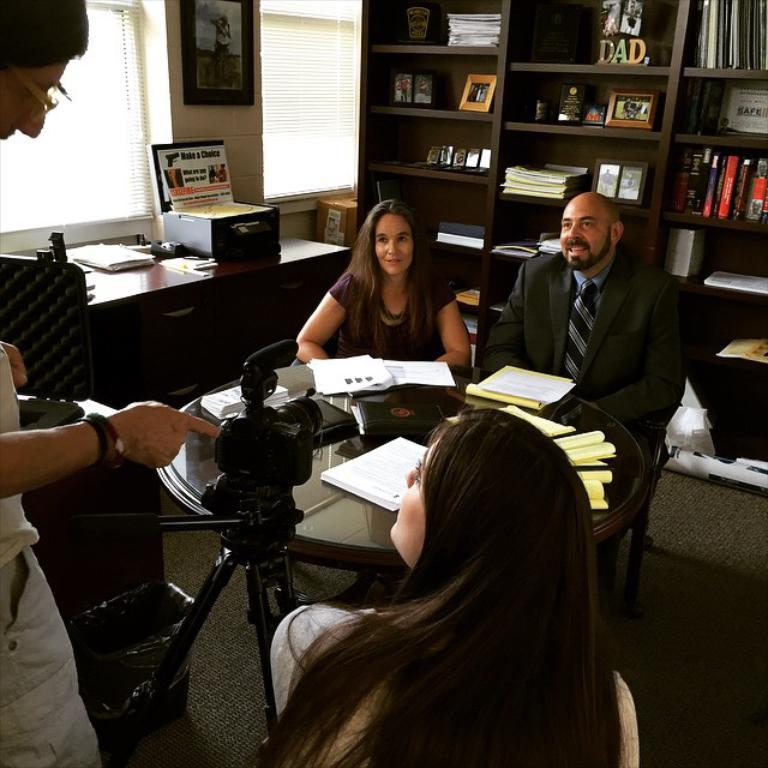<image>
Describe the image concisely. Group of politician around a table by a sign that says Make a Choice 